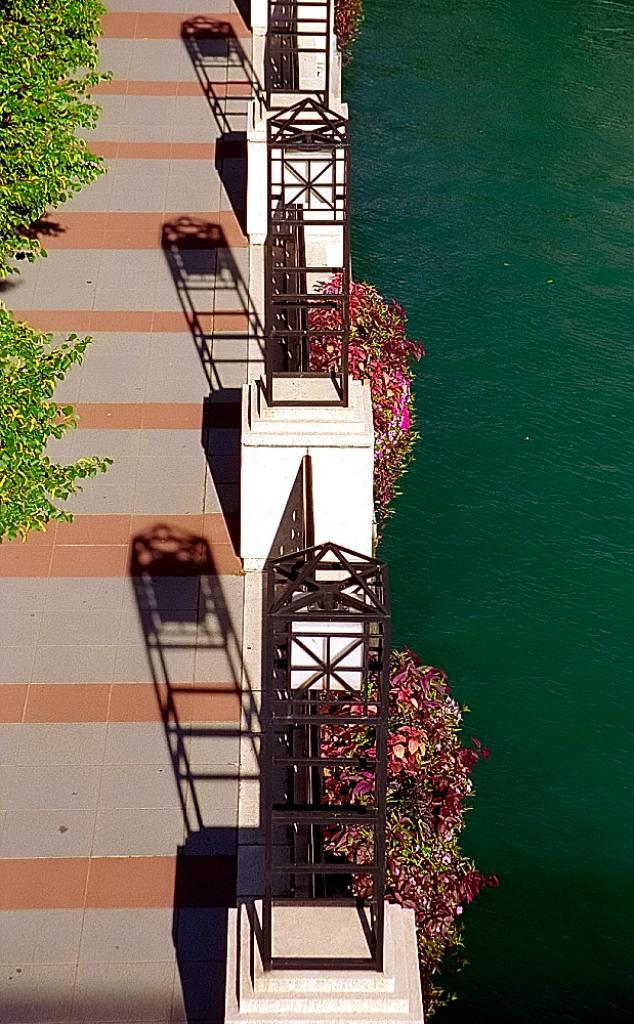What structure is visible on the edge of the image? There is a balcony in the image. What can be seen on the left side of the balcony? There are two trees on the left side of the balcony. What type of vegetation is present beside the wall of the balcony? There are colorful plants beside the wall of the balcony. What is located beside the plants? There is a water surface beside the plants. What type of locket is floating on the water surface in the image? There is no locket present in the image; it only features a balcony, trees, plants, and a water surface. What type of vessel is visible on the balcony in the image? There is no vessel present on the balcony in the image. 